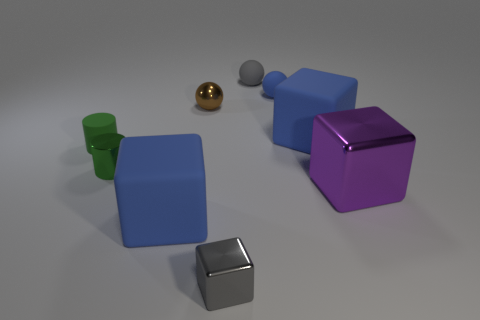What material is the small blue object?
Keep it short and to the point. Rubber. Is there a blue thing of the same size as the gray cube?
Your response must be concise. Yes. There is a gray block that is the same size as the blue sphere; what material is it?
Offer a terse response. Metal. What number of small objects are there?
Your answer should be compact. 6. There is a blue rubber thing on the left side of the tiny gray block; what is its size?
Your answer should be compact. Large. Are there an equal number of green metal cylinders that are behind the large purple object and green metal things?
Offer a very short reply. Yes. Are there any brown metal things of the same shape as the green metallic object?
Your answer should be compact. No. The small matte thing that is in front of the gray sphere and left of the blue sphere has what shape?
Your answer should be compact. Cylinder. Is the purple block made of the same material as the blue block that is on the left side of the brown ball?
Offer a very short reply. No. There is a tiny green rubber thing; are there any small balls in front of it?
Your answer should be compact. No. 